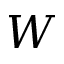Convert formula to latex. <formula><loc_0><loc_0><loc_500><loc_500>W</formula> 